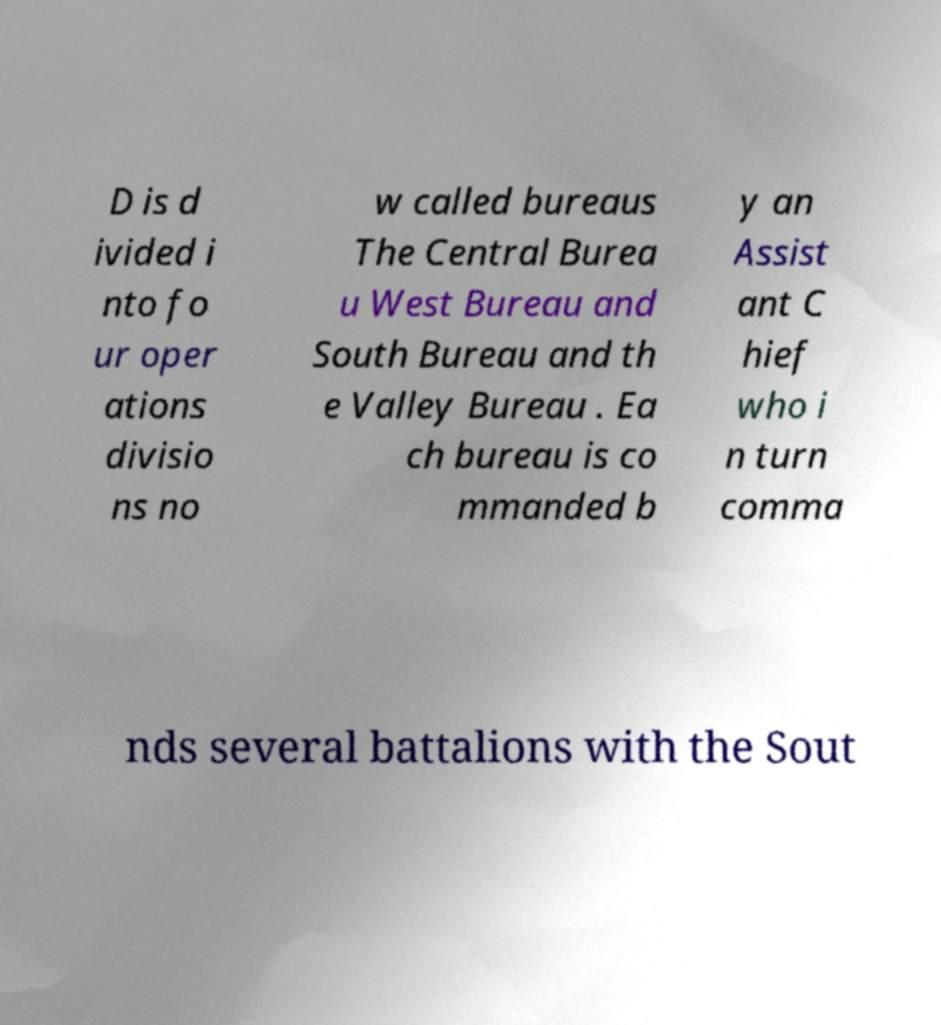For documentation purposes, I need the text within this image transcribed. Could you provide that? D is d ivided i nto fo ur oper ations divisio ns no w called bureaus The Central Burea u West Bureau and South Bureau and th e Valley Bureau . Ea ch bureau is co mmanded b y an Assist ant C hief who i n turn comma nds several battalions with the Sout 